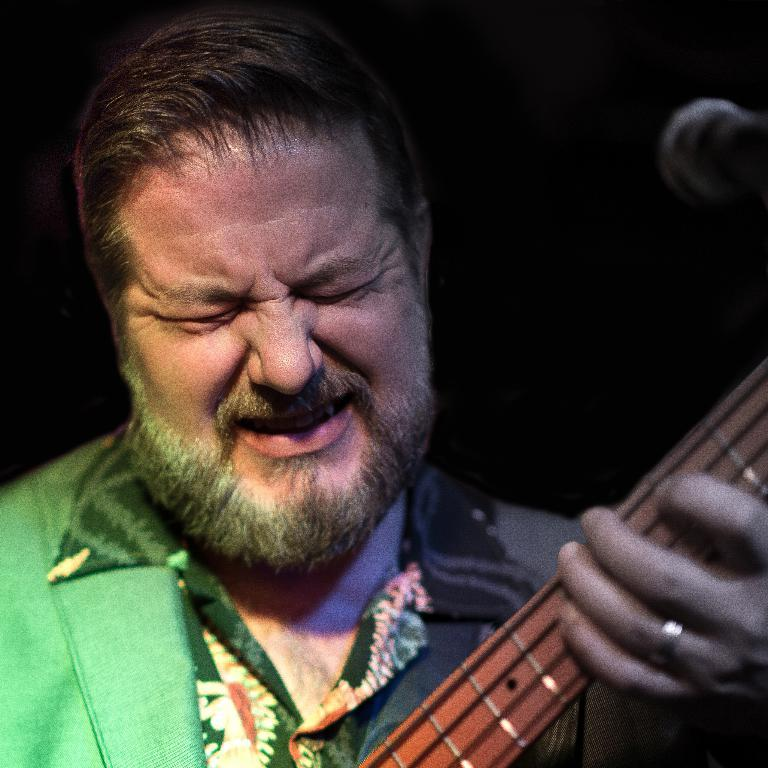Who is the main subject in the image? There is a man in the image. What is the man wearing? The man is wearing a green shirt. What is the man holding in the image? The man is holding a music instrument. What is in front of the man? There is a microphone in front of the man. What color is the background of the image? The background of the image is black. What type of oil can be seen dripping from the man's shirt in the image? There is no oil present in the image, and the man's shirt is not depicted as having any dripping substances. 